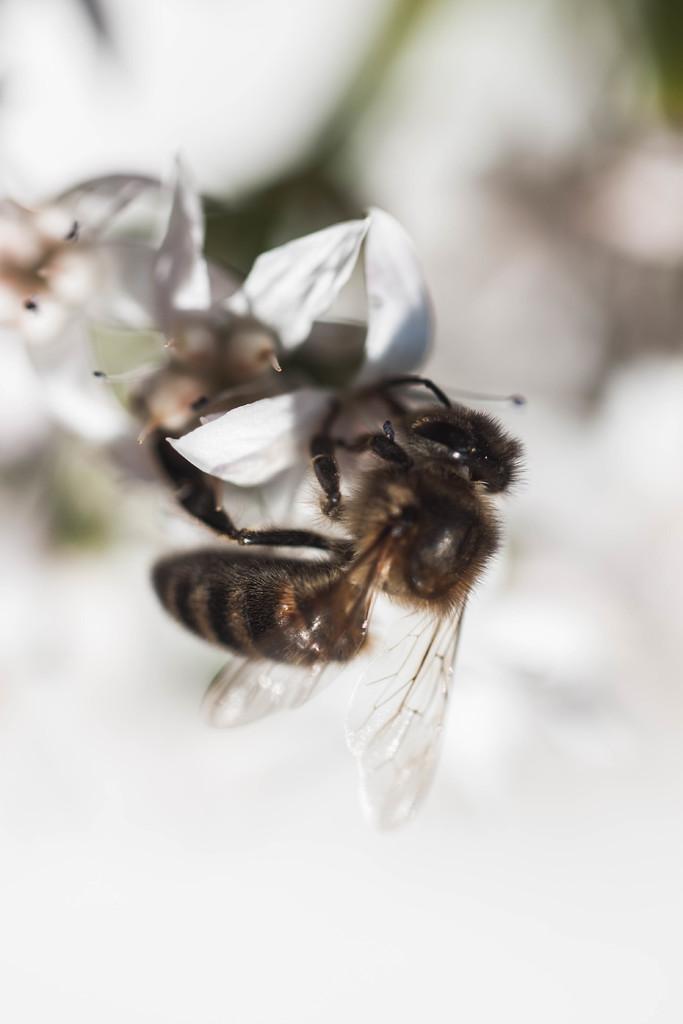Could you give a brief overview of what you see in this image? In this image there is a bee on a flower. 